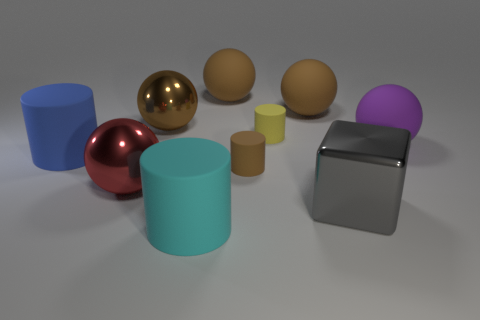Subtract all yellow cylinders. How many brown balls are left? 3 Subtract all brown cylinders. How many cylinders are left? 3 Subtract all brown cylinders. How many cylinders are left? 3 Subtract all cyan balls. Subtract all brown cylinders. How many balls are left? 5 Subtract all blocks. How many objects are left? 9 Subtract all small brown cylinders. Subtract all big shiny objects. How many objects are left? 6 Add 8 brown metal objects. How many brown metal objects are left? 9 Add 7 gray cubes. How many gray cubes exist? 8 Subtract 0 yellow spheres. How many objects are left? 10 